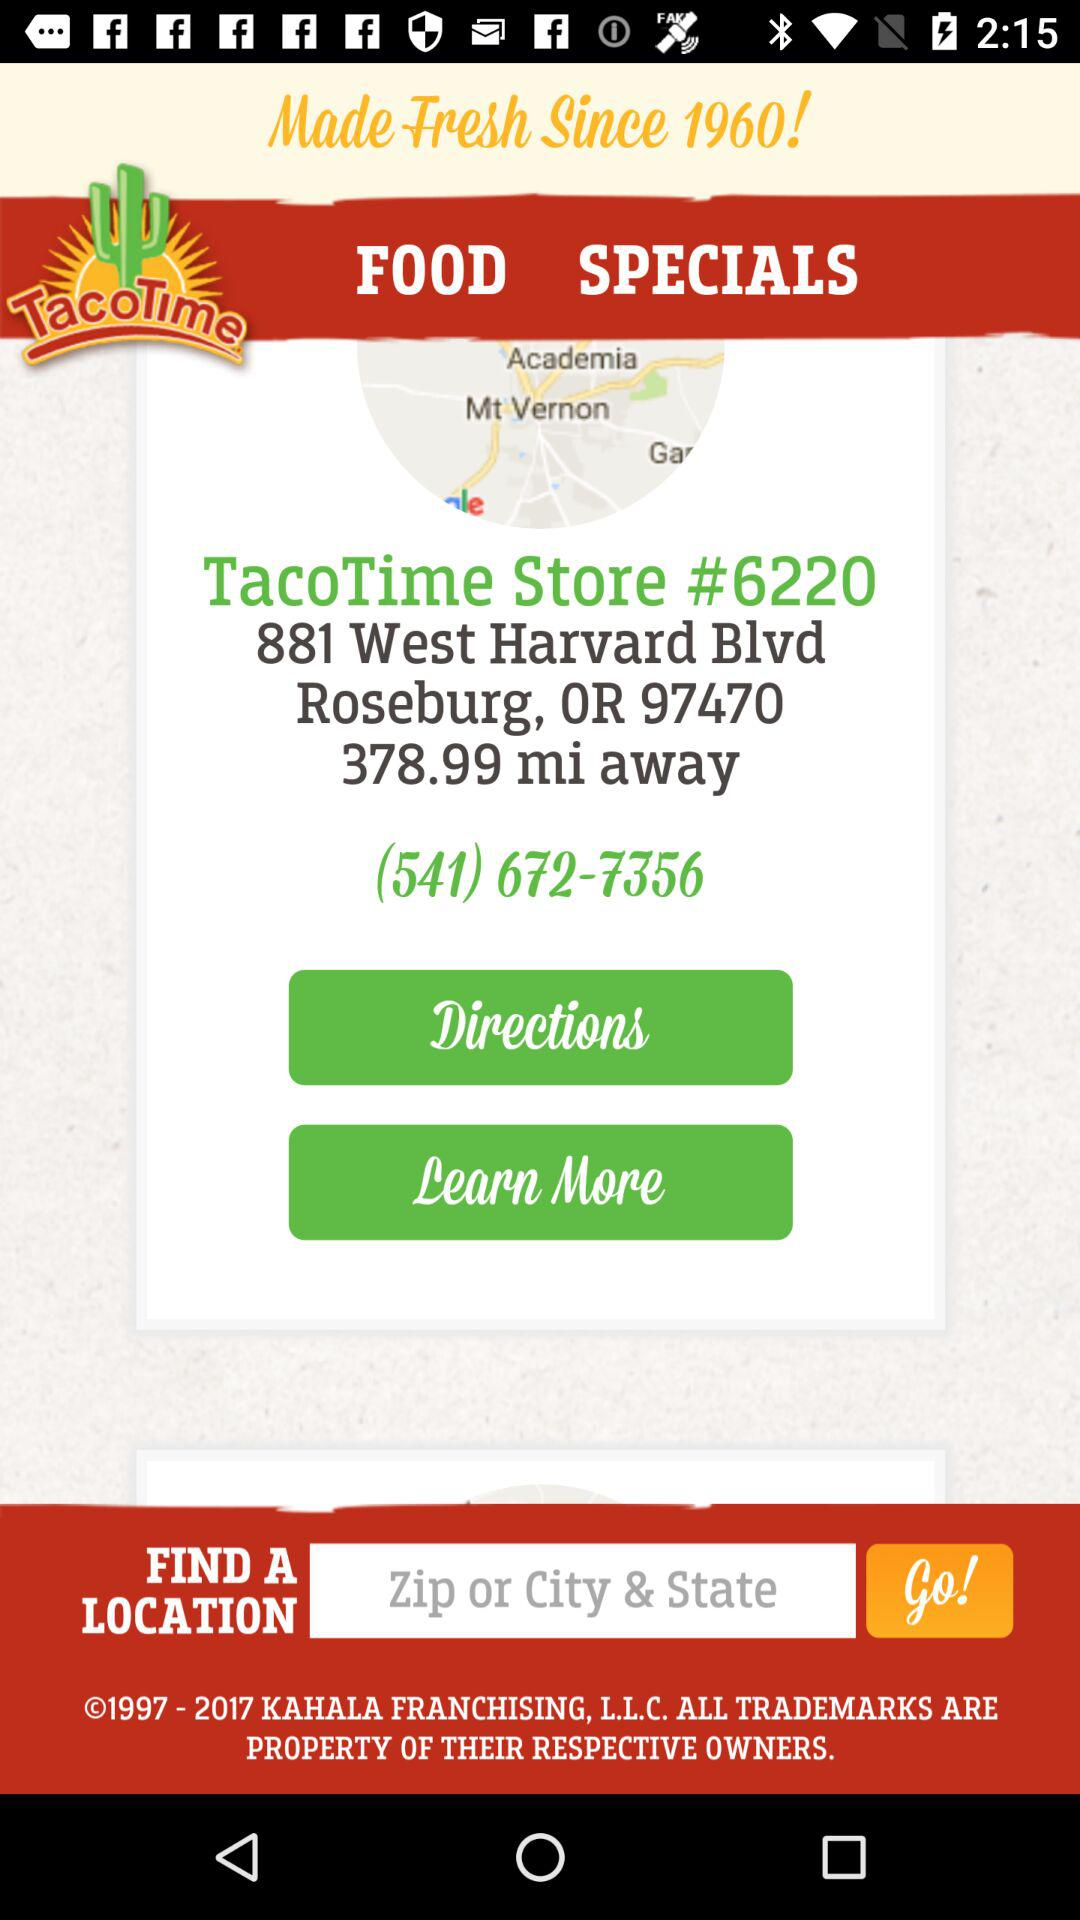What is the store address? The store address is 881 West Harvard Blvd Roseburg, OR 97470. 